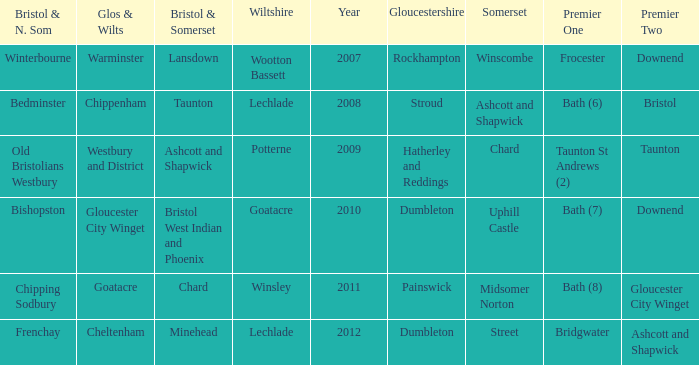What is the latest year where glos & wilts is warminster? 2007.0. 